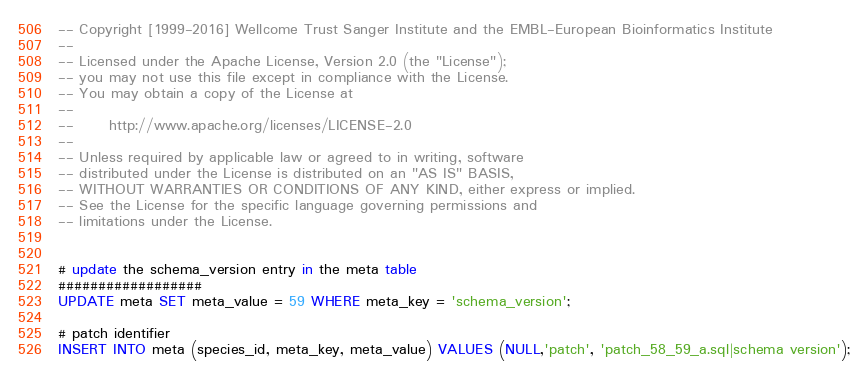<code> <loc_0><loc_0><loc_500><loc_500><_SQL_>-- Copyright [1999-2016] Wellcome Trust Sanger Institute and the EMBL-European Bioinformatics Institute
-- 
-- Licensed under the Apache License, Version 2.0 (the "License");
-- you may not use this file except in compliance with the License.
-- You may obtain a copy of the License at
-- 
--      http://www.apache.org/licenses/LICENSE-2.0
-- 
-- Unless required by applicable law or agreed to in writing, software
-- distributed under the License is distributed on an "AS IS" BASIS,
-- WITHOUT WARRANTIES OR CONDITIONS OF ANY KIND, either express or implied.
-- See the License for the specific language governing permissions and
-- limitations under the License.


# update the schema_version entry in the meta table
##################
UPDATE meta SET meta_value = 59 WHERE meta_key = 'schema_version';

# patch identifier
INSERT INTO meta (species_id, meta_key, meta_value) VALUES (NULL,'patch', 'patch_58_59_a.sql|schema version');
</code> 